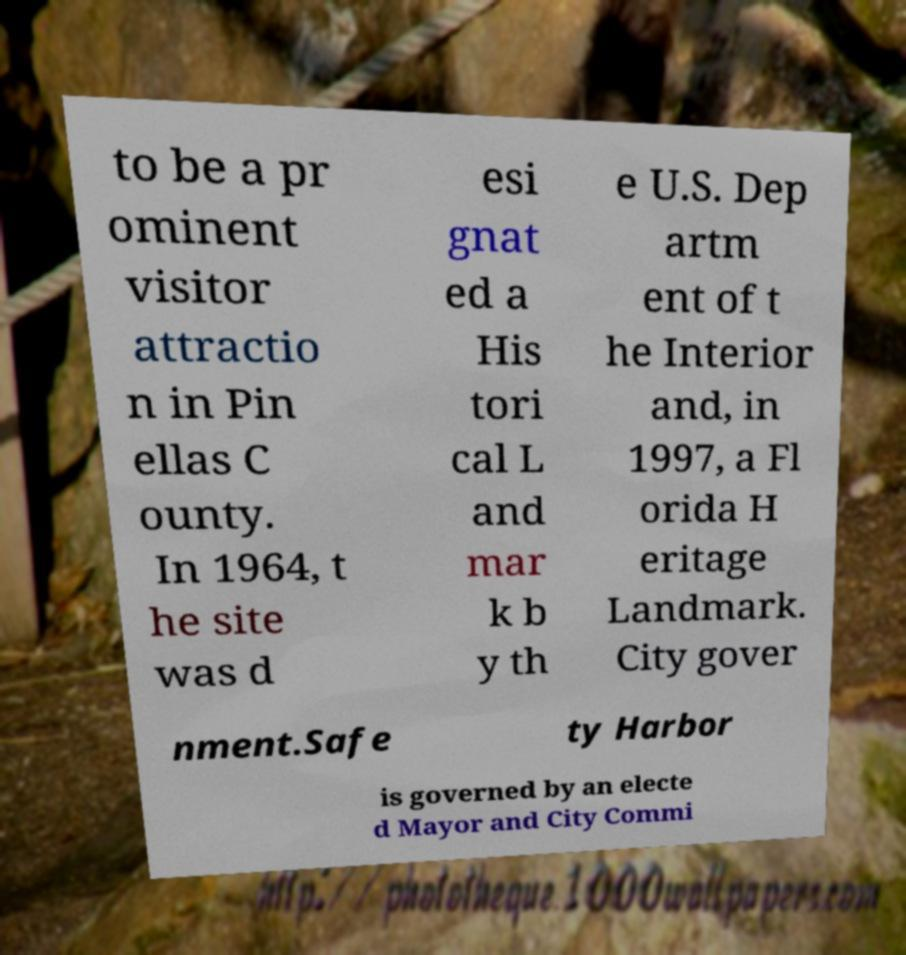Please read and relay the text visible in this image. What does it say? to be a pr ominent visitor attractio n in Pin ellas C ounty. In 1964, t he site was d esi gnat ed a His tori cal L and mar k b y th e U.S. Dep artm ent of t he Interior and, in 1997, a Fl orida H eritage Landmark. City gover nment.Safe ty Harbor is governed by an electe d Mayor and City Commi 